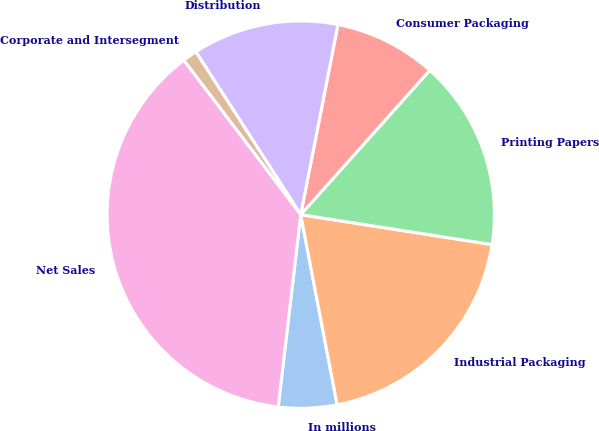Convert chart to OTSL. <chart><loc_0><loc_0><loc_500><loc_500><pie_chart><fcel>In millions<fcel>Industrial Packaging<fcel>Printing Papers<fcel>Consumer Packaging<fcel>Distribution<fcel>Corporate and Intersegment<fcel>Net Sales<nl><fcel>4.87%<fcel>19.52%<fcel>15.86%<fcel>8.53%<fcel>12.19%<fcel>1.21%<fcel>37.83%<nl></chart> 